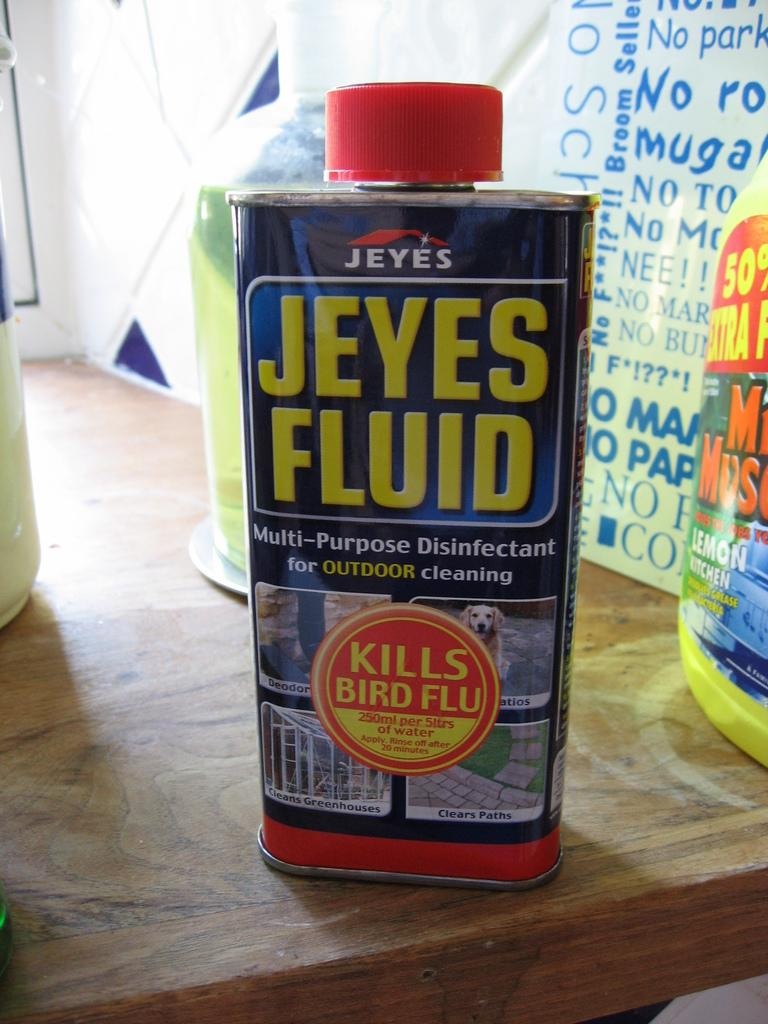What piece of furniture is present in the image? There is a table in the image. What object is placed on the table? There is a tin and bottles on the table. What can be seen in the background of the image? There is a board and a wall visible in the background of the image. What title is given to the person in jail in the image? There is no person in jail in the image, and therefore no title can be assigned. 